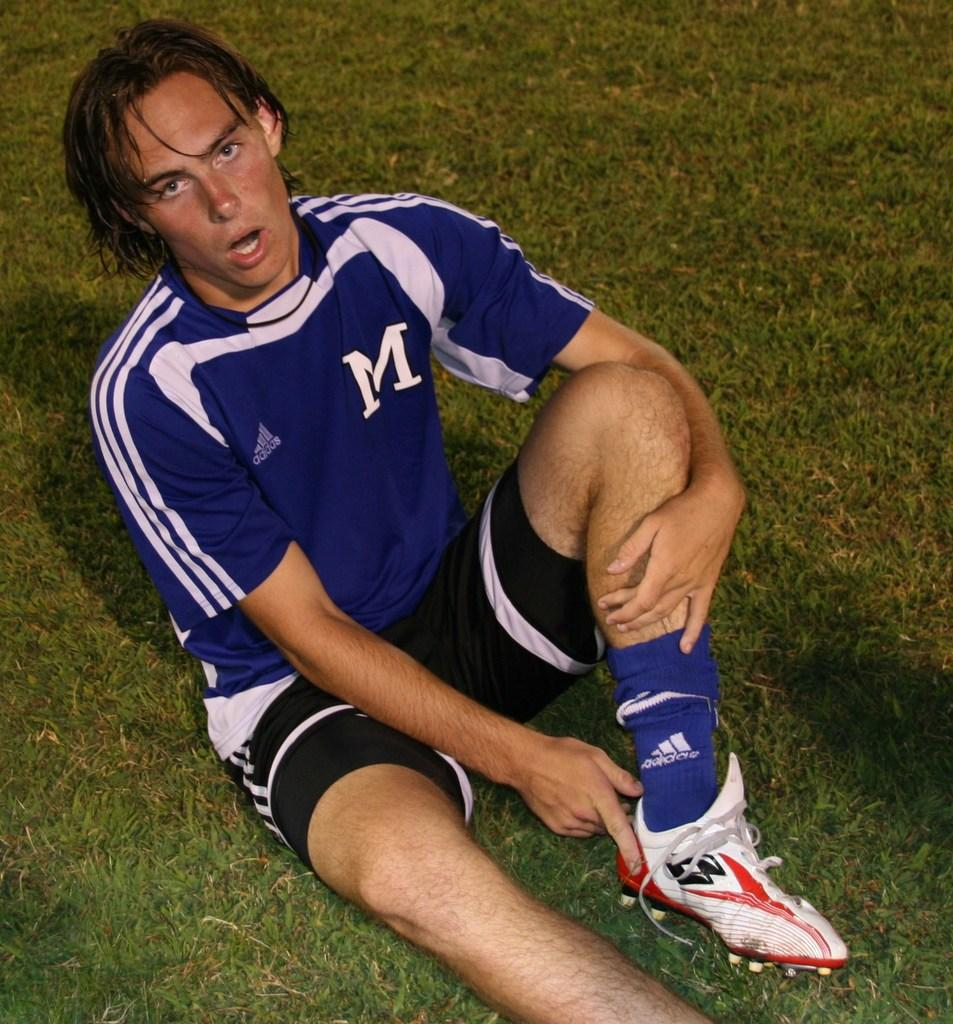Who is present in the image? There is a person in the image. What is the person doing in the image? The person is sitting on the ground. What type of copper object is being used by the person in the image? There is no copper object present in the image; the person is simply sitting on the ground. 